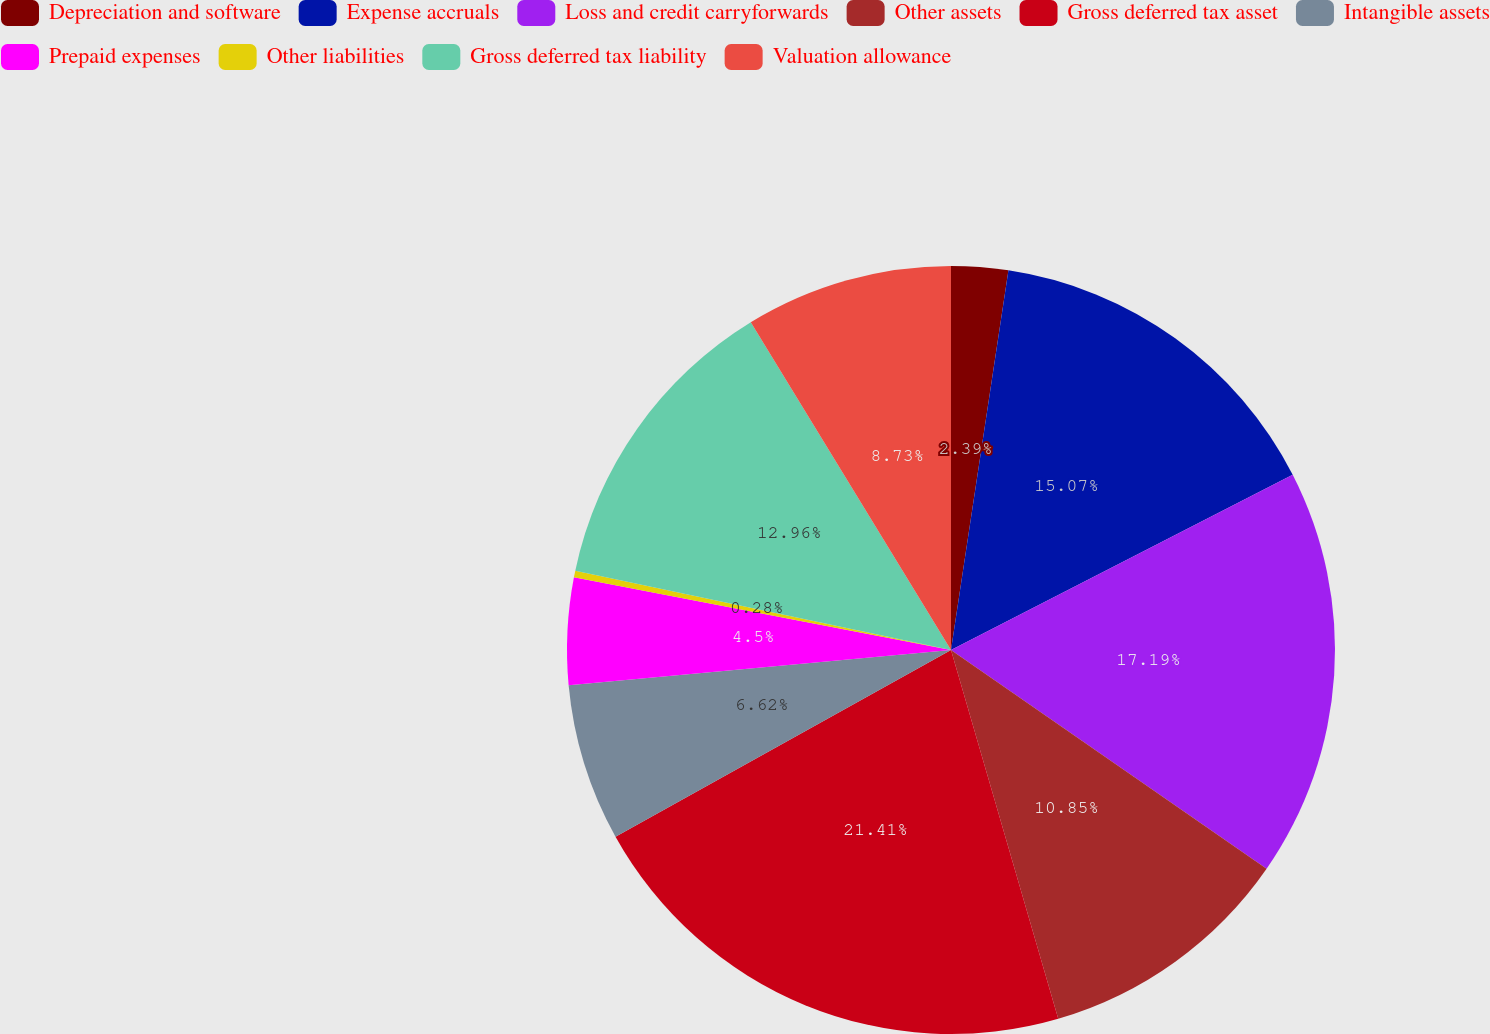Convert chart to OTSL. <chart><loc_0><loc_0><loc_500><loc_500><pie_chart><fcel>Depreciation and software<fcel>Expense accruals<fcel>Loss and credit carryforwards<fcel>Other assets<fcel>Gross deferred tax asset<fcel>Intangible assets<fcel>Prepaid expenses<fcel>Other liabilities<fcel>Gross deferred tax liability<fcel>Valuation allowance<nl><fcel>2.39%<fcel>15.07%<fcel>17.19%<fcel>10.85%<fcel>21.42%<fcel>6.62%<fcel>4.5%<fcel>0.28%<fcel>12.96%<fcel>8.73%<nl></chart> 